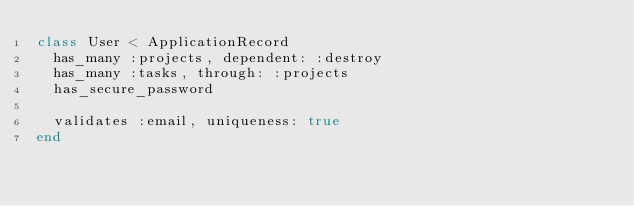<code> <loc_0><loc_0><loc_500><loc_500><_Ruby_>class User < ApplicationRecord
  has_many :projects, dependent: :destroy
  has_many :tasks, through: :projects
  has_secure_password

  validates :email, uniqueness: true
end
</code> 